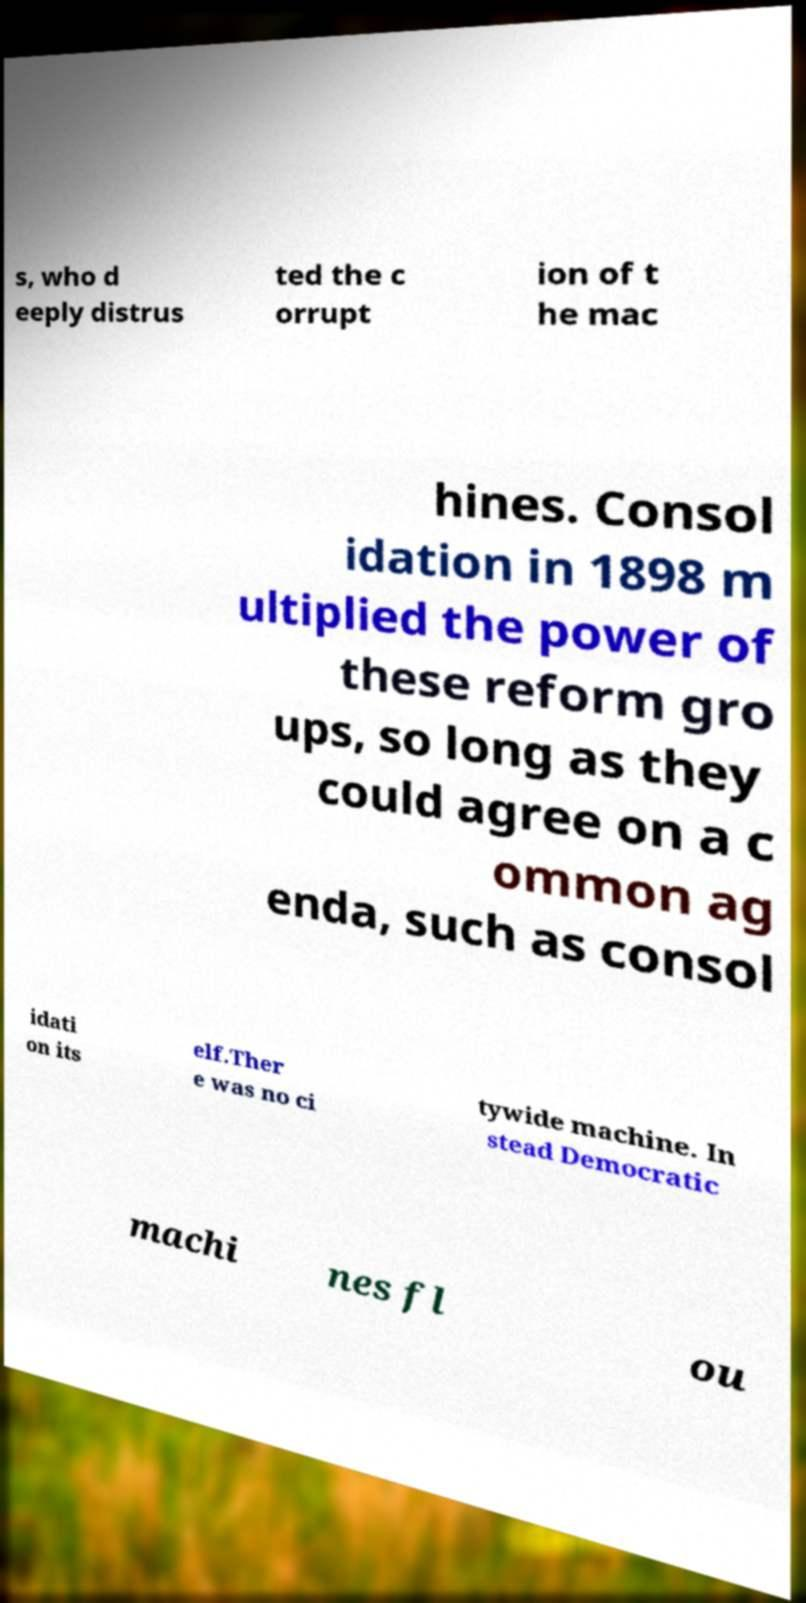What messages or text are displayed in this image? I need them in a readable, typed format. s, who d eeply distrus ted the c orrupt ion of t he mac hines. Consol idation in 1898 m ultiplied the power of these reform gro ups, so long as they could agree on a c ommon ag enda, such as consol idati on its elf.Ther e was no ci tywide machine. In stead Democratic machi nes fl ou 